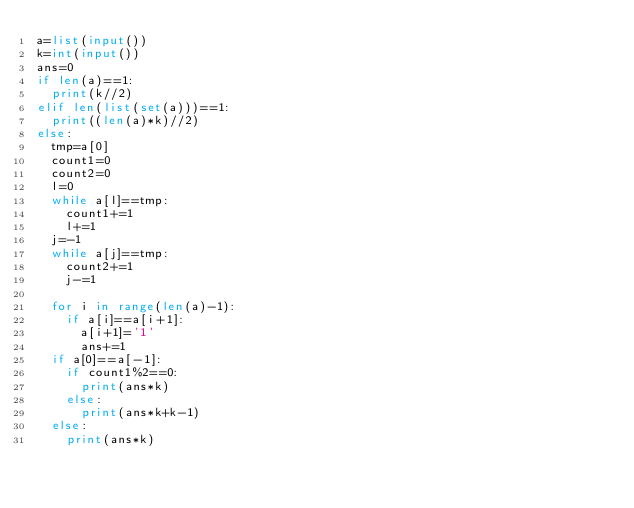<code> <loc_0><loc_0><loc_500><loc_500><_Python_>a=list(input())
k=int(input())
ans=0
if len(a)==1:
  print(k//2)
elif len(list(set(a)))==1:
  print((len(a)*k)//2)
else:  
  tmp=a[0]
  count1=0
  count2=0
  l=0
  while a[l]==tmp:
    count1+=1
    l+=1
  j=-1
  while a[j]==tmp:
    count2+=1
    j-=1
    
  for i in range(len(a)-1):
    if a[i]==a[i+1]:
      a[i+1]='1'
      ans+=1
  if a[0]==a[-1]:
    if count1%2==0:
      print(ans*k)
    else:
      print(ans*k+k-1)
  else:
    print(ans*k)</code> 